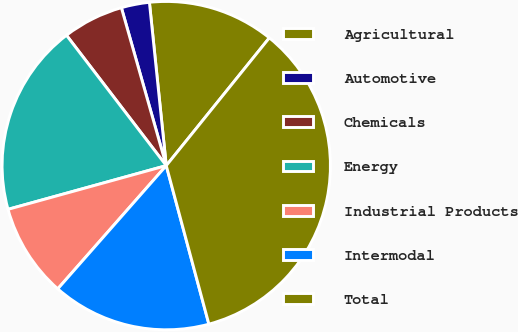<chart> <loc_0><loc_0><loc_500><loc_500><pie_chart><fcel>Agricultural<fcel>Automotive<fcel>Chemicals<fcel>Energy<fcel>Industrial Products<fcel>Intermodal<fcel>Total<nl><fcel>12.44%<fcel>2.77%<fcel>5.99%<fcel>18.89%<fcel>9.22%<fcel>15.67%<fcel>35.01%<nl></chart> 